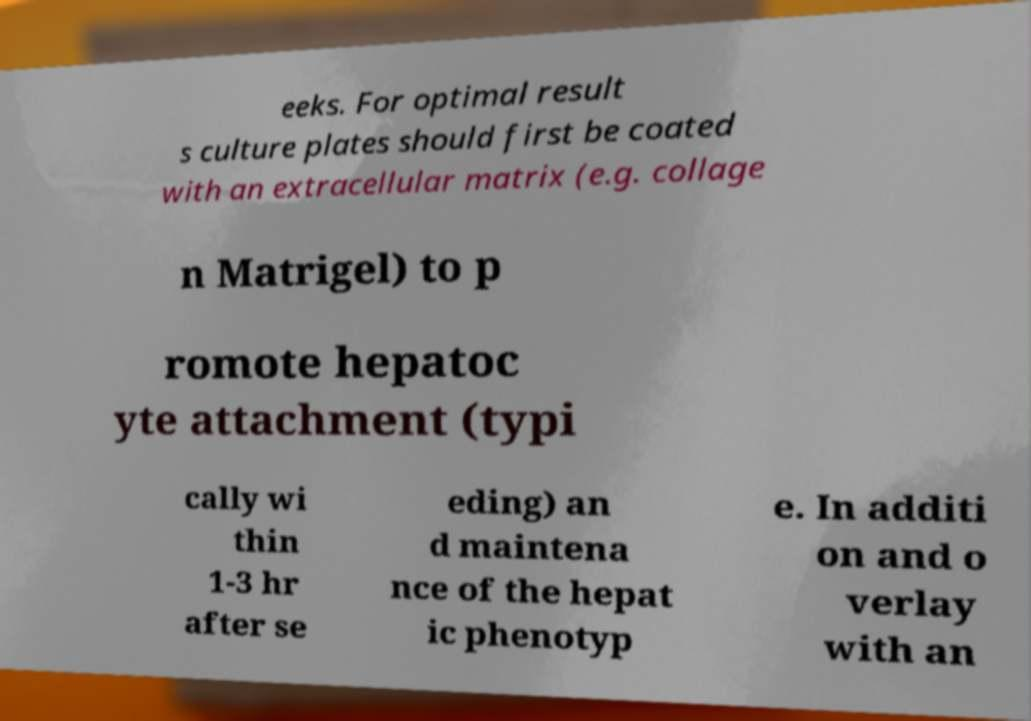Could you assist in decoding the text presented in this image and type it out clearly? eeks. For optimal result s culture plates should first be coated with an extracellular matrix (e.g. collage n Matrigel) to p romote hepatoc yte attachment (typi cally wi thin 1-3 hr after se eding) an d maintena nce of the hepat ic phenotyp e. In additi on and o verlay with an 